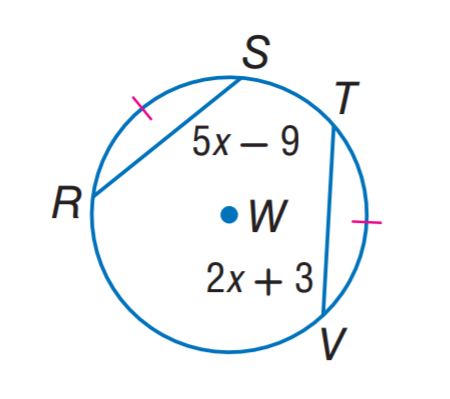Answer the mathemtical geometry problem and directly provide the correct option letter.
Question: In \odot W, \widehat R S \cong \widehat T V. Find R S.
Choices: A: 9 B: 11 C: 13 D: 22 B 